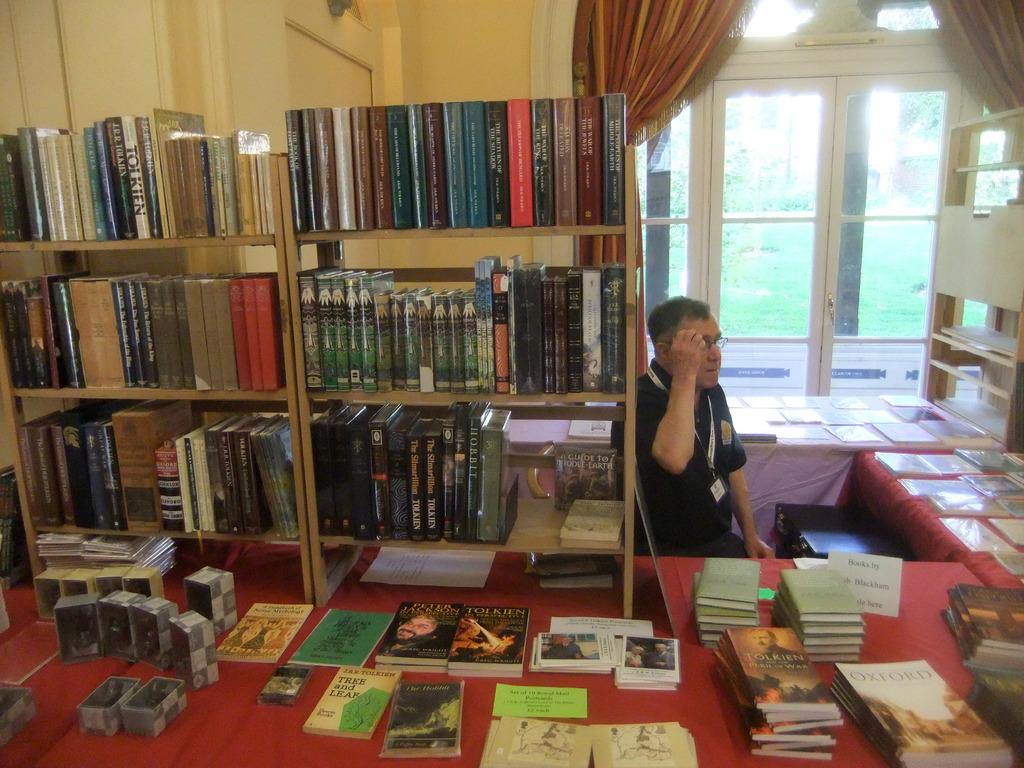<image>
Present a compact description of the photo's key features. Several books on the table with sign, "books by Blackham". 